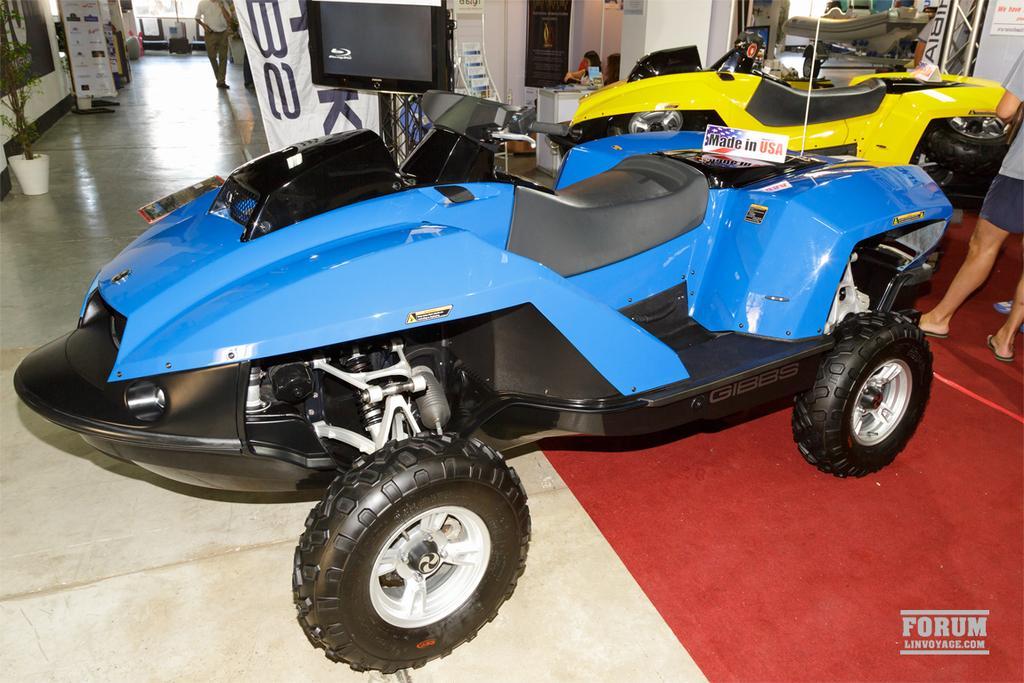How would you summarize this image in a sentence or two? In this image, we can see vehicles. At the bottom, there is a floor. Background we can see few people, television, banners, plant, rods, few objects. Few are sitting, standing and walking. Right side bottom, we can see a watermark. 